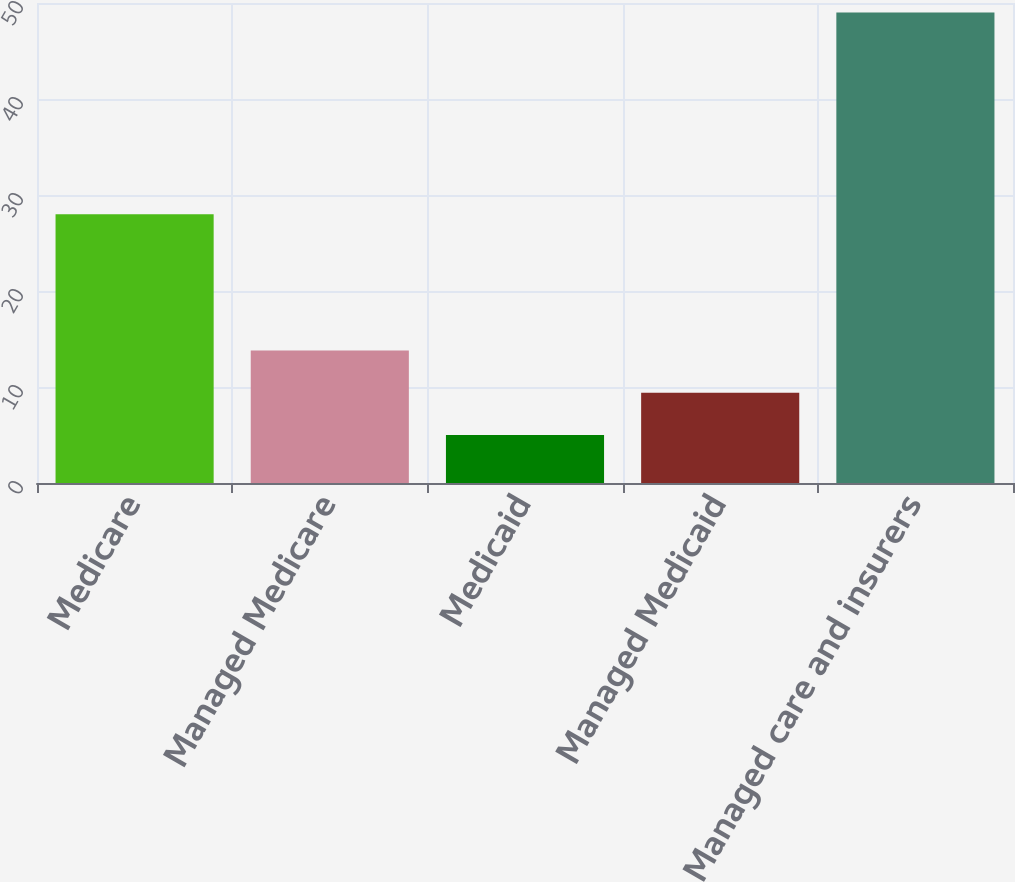Convert chart to OTSL. <chart><loc_0><loc_0><loc_500><loc_500><bar_chart><fcel>Medicare<fcel>Managed Medicare<fcel>Medicaid<fcel>Managed Medicaid<fcel>Managed care and insurers<nl><fcel>28<fcel>13.8<fcel>5<fcel>9.4<fcel>49<nl></chart> 